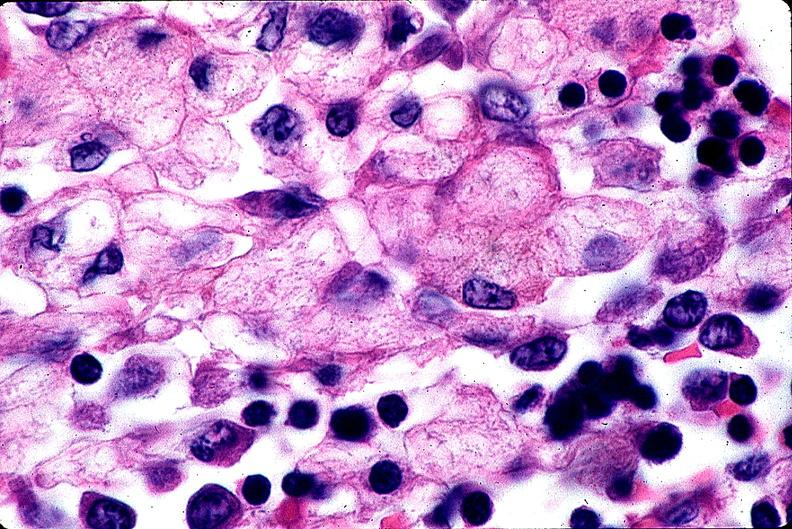what is present?
Answer the question using a single word or phrase. Hematologic 